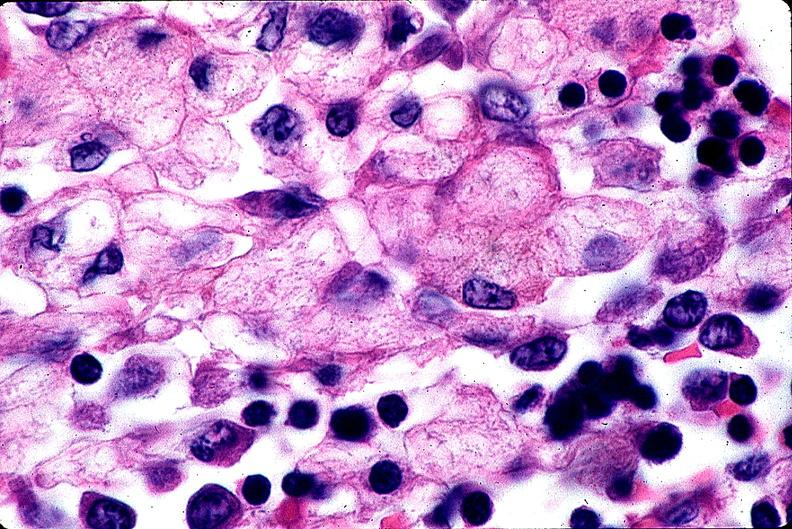what is present?
Answer the question using a single word or phrase. Hematologic 